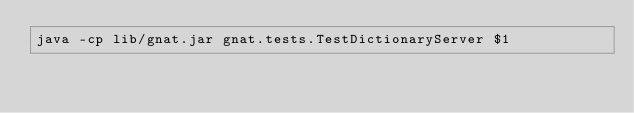Convert code to text. <code><loc_0><loc_0><loc_500><loc_500><_Bash_>java -cp lib/gnat.jar gnat.tests.TestDictionaryServer $1</code> 